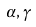<formula> <loc_0><loc_0><loc_500><loc_500>\alpha , \gamma</formula> 